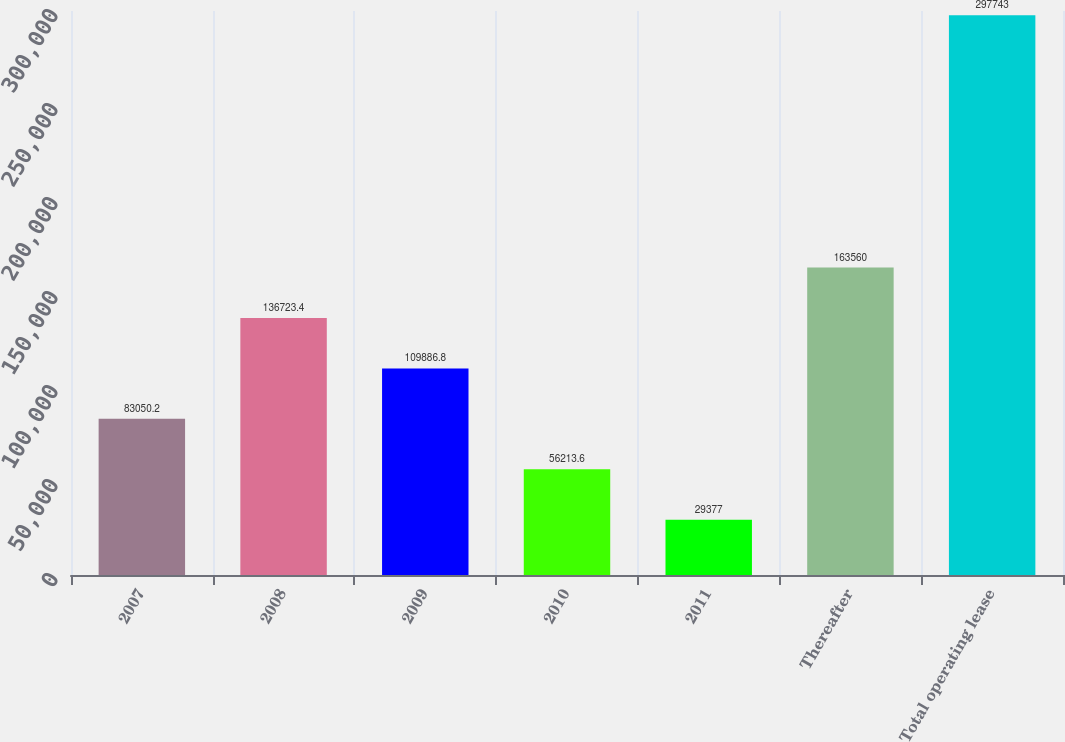Convert chart to OTSL. <chart><loc_0><loc_0><loc_500><loc_500><bar_chart><fcel>2007<fcel>2008<fcel>2009<fcel>2010<fcel>2011<fcel>Thereafter<fcel>Total operating lease<nl><fcel>83050.2<fcel>136723<fcel>109887<fcel>56213.6<fcel>29377<fcel>163560<fcel>297743<nl></chart> 